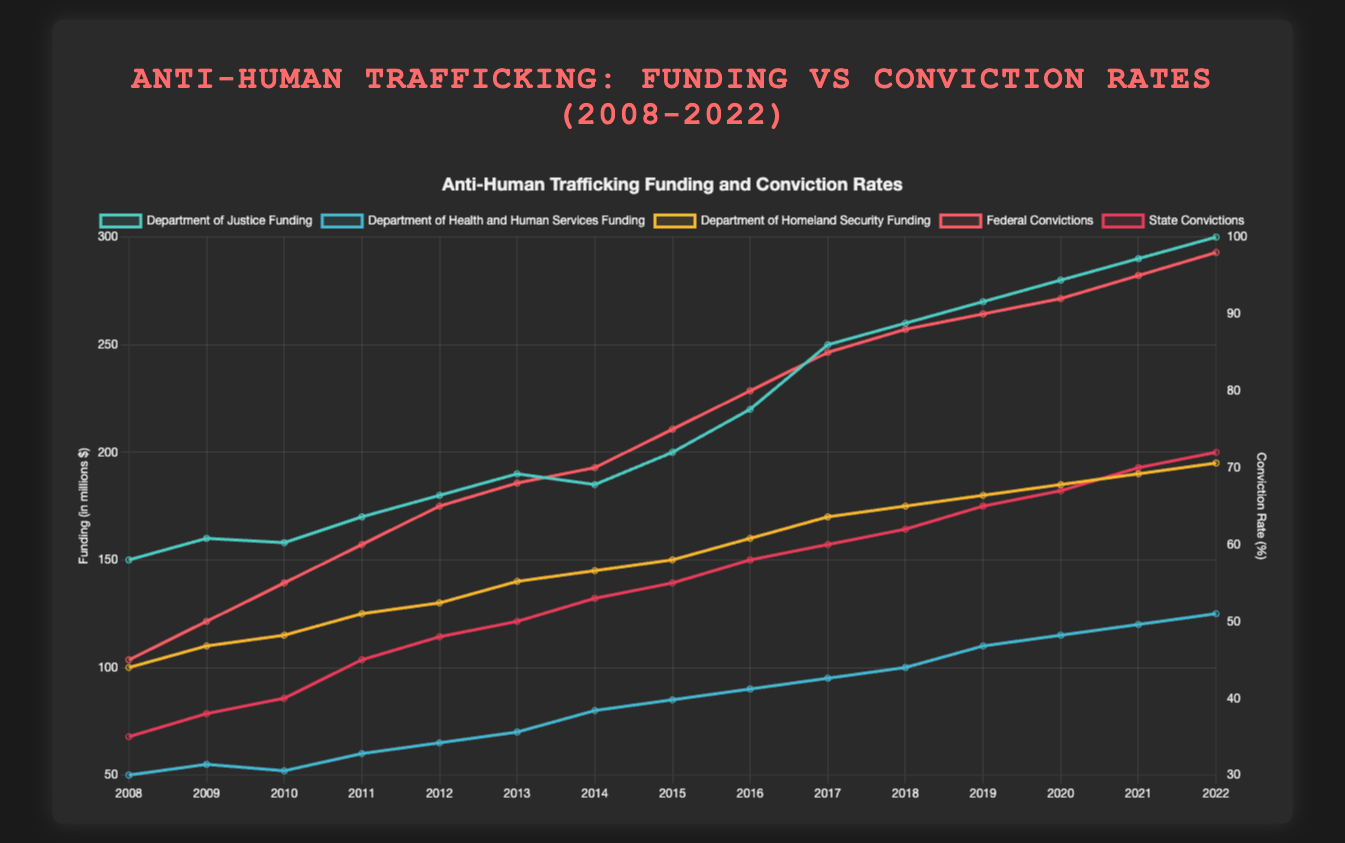What's the total funding allocated by the Department of Justice in 2020? First, locate the funding amount for the Department of Justice in 2020. The figure shows it as $280 million.
Answer: $280 million How did the federal conviction rates change from 2015 to 2020? To find the change, subtract the federal conviction rate in 2015 (75%) from that in 2020 (92%). The change is 92 - 75 = 17 percentage points.
Answer: 17 percentage points Which department had the highest increase in funding from 2012 to 2022? Calculate the increase for each department:
1. DOJ: 300 - 180 = 120 million 
2. HHS: 125 - 65 = 60 million 
3. DHS: 195 - 130 = 65 million 
The Department of Justice had the highest increase.
Answer: Department of Justice What year had the highest federal conviction rate? Look for the highest point on the federal conviction rate line, which occurs in 2022 at 98%.
Answer: 2022 By how much did funding from the Department of Homeland Security increase from 2008 to 2022? Subtract the funding amount in 2008 from that in 2022 for DHS: 195 - 100 = 95 million dollars.
Answer: 95 million dollars Compare the conviction rates for federal and state levels in 2010. Which is higher and by how much? Find the conviction rates for 2010: Federal (55%), State (40%). Subtract state from federal: 55 - 40 = 15 percentage points, so the federal rate is higher by 15 percentage points.
Answer: Federal by 15 percentage points What's the average funding over the years for the Department of Health and Human Services? Sum the funding amounts from 2008 to 2022 for HHS: 50 + 55 + 52 + 60 + 65 + 70 + 80 + 85 + 90 + 95 + 100 + 110 + 115 + 120 + 125 = 1272. Divide by the number of years (15): 1272 / 15 = 84.8 million dollars.
Answer: 84.8 million dollars Did the funding allocated to anti-human trafficking initiatives show a consistent increase over the years? Examine the trend in the lines representing funding for each department. All lines show a general upward trend, indicating a consistent increase.
Answer: Yes Compare the funding trends for the Department of Justice and the Department of Homeland Security between 2008 and 2018. Which had a steeper increase? Calculate changes from 2008 to 2018 for both departments:
1. DOJ: 260 - 150 = 110 million
2. DHS: 175 - 100 = 75 million
The DOJ had a steeper increase (110 million vs. 75 million).
Answer: Department of Justice 